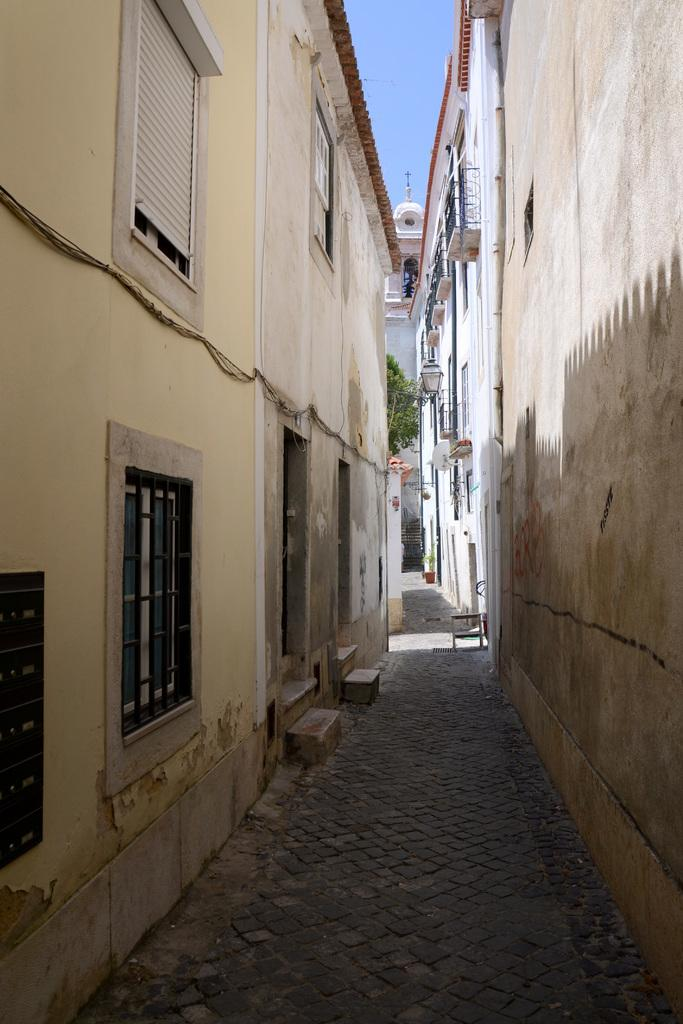What type of location is depicted in the image? There is a street in the image. What can be seen on the left side of the image? There are buildings on the left side of the image. What can be seen on the right side of the image? There are buildings on the right side of the image. What type of vegetation is visible in the background of the image? There is a tree in the background of the image. What is visible in the sky in the background of the image? The sky is clear and visible in the background of the image. Can you describe the liquid that is flowing down the street in the image? There is no liquid flowing down the street in the image; it is a dry street with buildings and a tree in the background. 